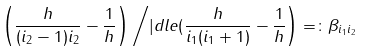Convert formula to latex. <formula><loc_0><loc_0><loc_500><loc_500>\left ( { \frac { h } { ( i _ { 2 } - 1 ) i _ { 2 } } - \frac { 1 } { h } } \right ) \left / | d l e ( { \frac { h } { i _ { 1 } ( i _ { 1 } + 1 ) } - \frac { 1 } { h } } \right ) = \colon \beta _ { i _ { 1 } i _ { 2 } }</formula> 